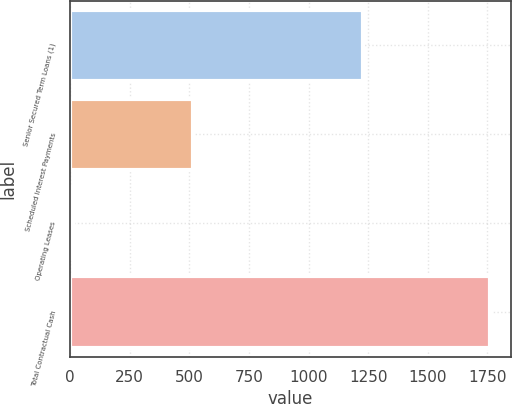Convert chart to OTSL. <chart><loc_0><loc_0><loc_500><loc_500><bar_chart><fcel>Senior Secured Term Loans (1)<fcel>Scheduled Interest Payments<fcel>Operating Leases<fcel>Total Contractual Cash<nl><fcel>1230.3<fcel>516.4<fcel>9.9<fcel>1761.5<nl></chart> 